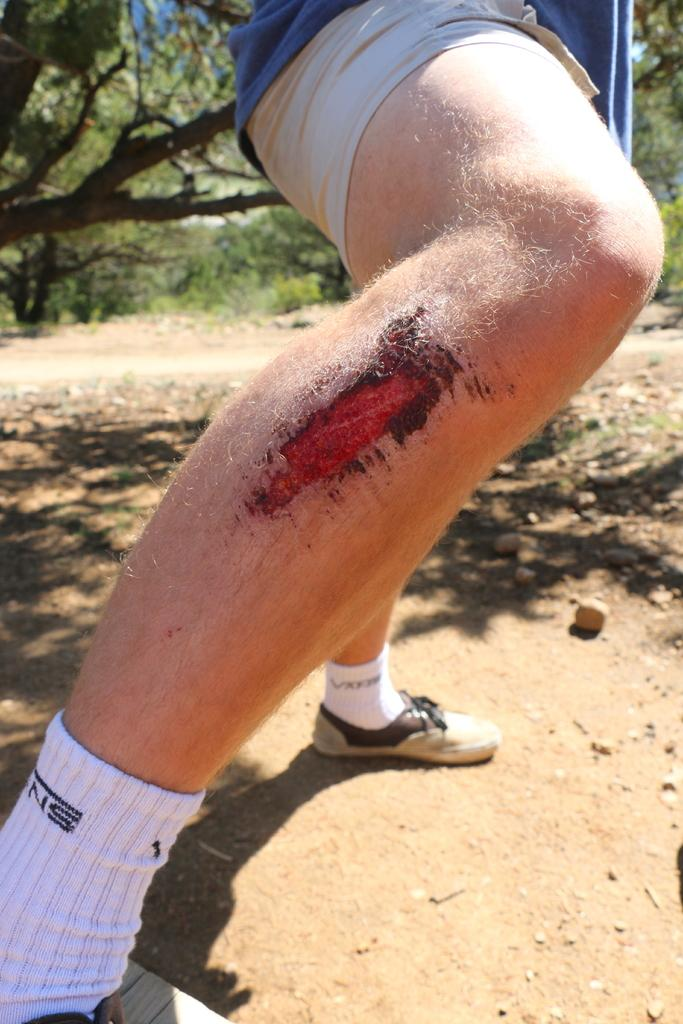What part of a person's body is visible in the image? There is a person's leg in the image. What is unique about the leg in the image? The leg has a red heart on it. What type of natural environment is visible in the background of the image? There is grass and trees in the background of the image. How many snails can be seen crawling on the red heart in the image? There are no snails visible in the image, as it only features a person's leg with a red heart on it and a natural background. 